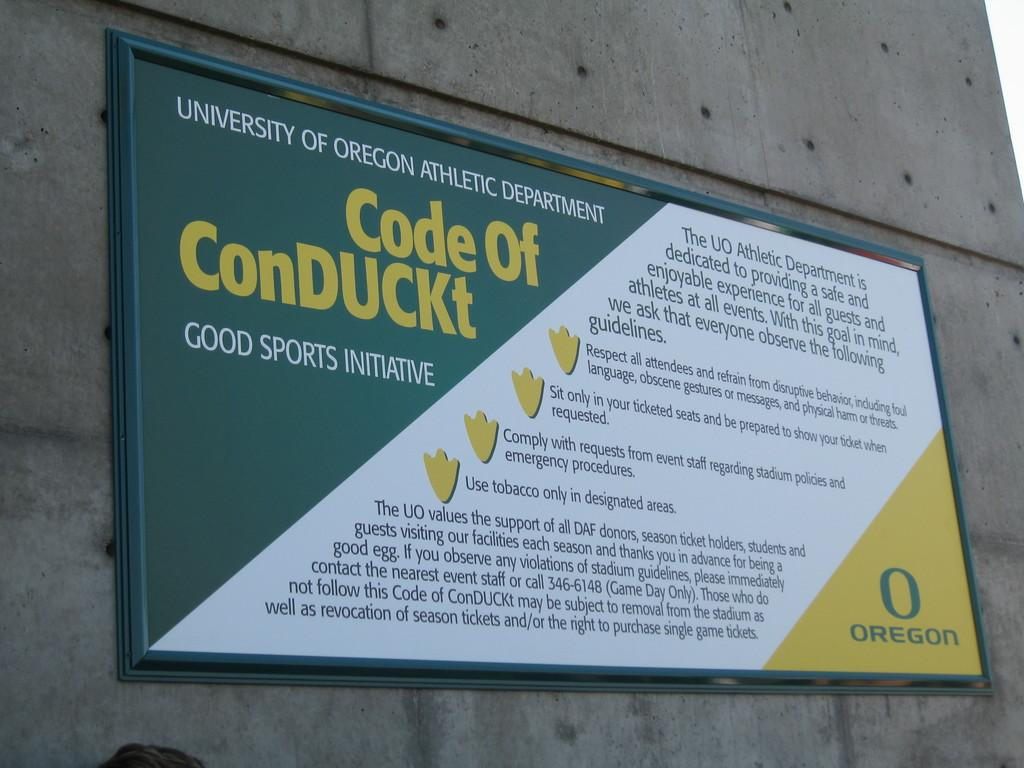<image>
Present a compact description of the photo's key features. A sign is posted on a concrete wall by the University of Oregon stating the Code of ConDuckt. 